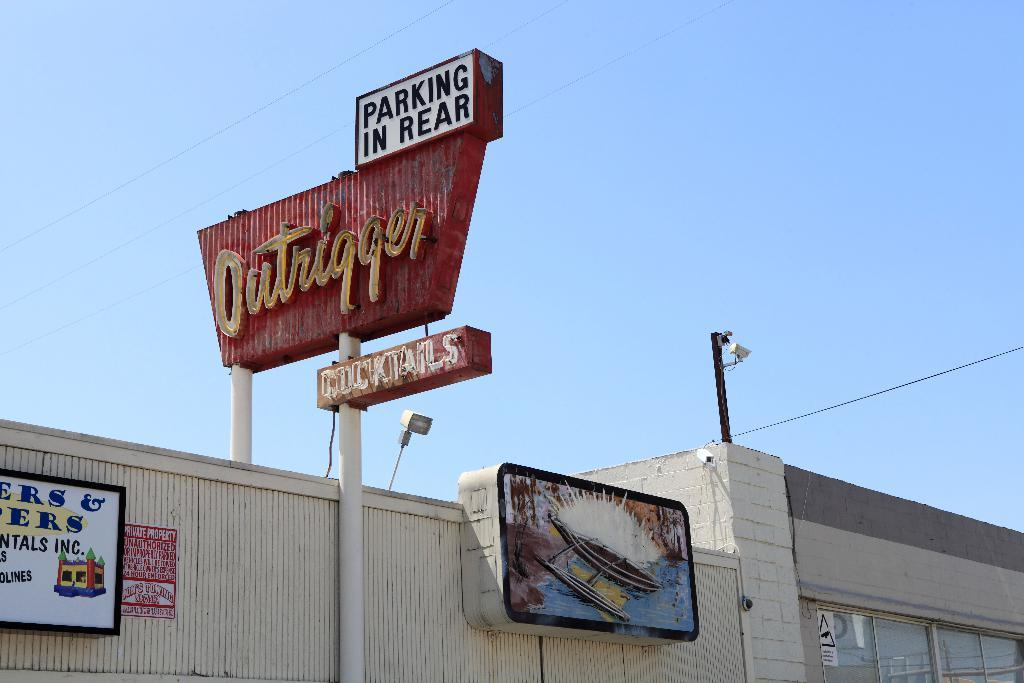<image>
Present a compact description of the photo's key features. The Outrigger restaurant has a sign that reads both Cocktails and parking in the rear. 